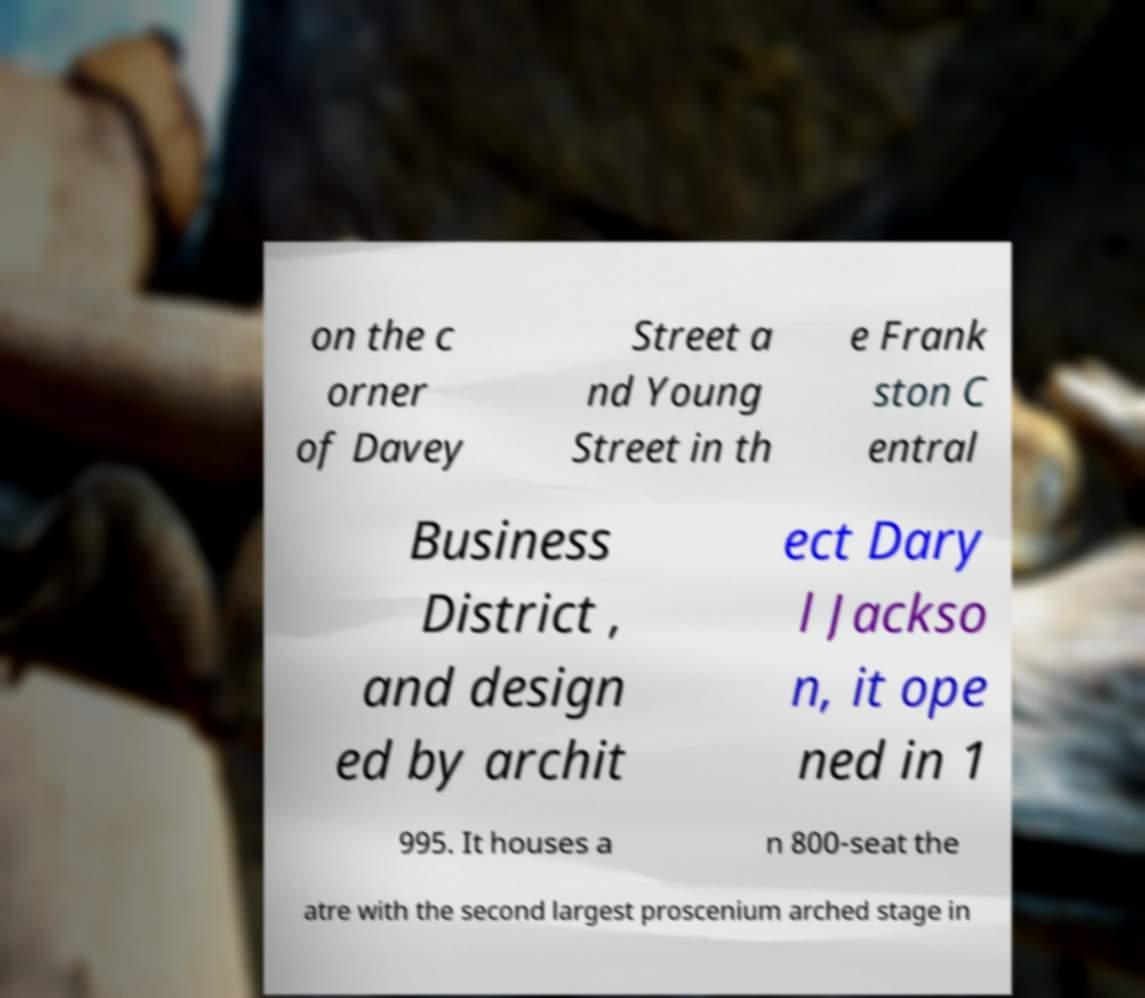What messages or text are displayed in this image? I need them in a readable, typed format. on the c orner of Davey Street a nd Young Street in th e Frank ston C entral Business District , and design ed by archit ect Dary l Jackso n, it ope ned in 1 995. It houses a n 800-seat the atre with the second largest proscenium arched stage in 